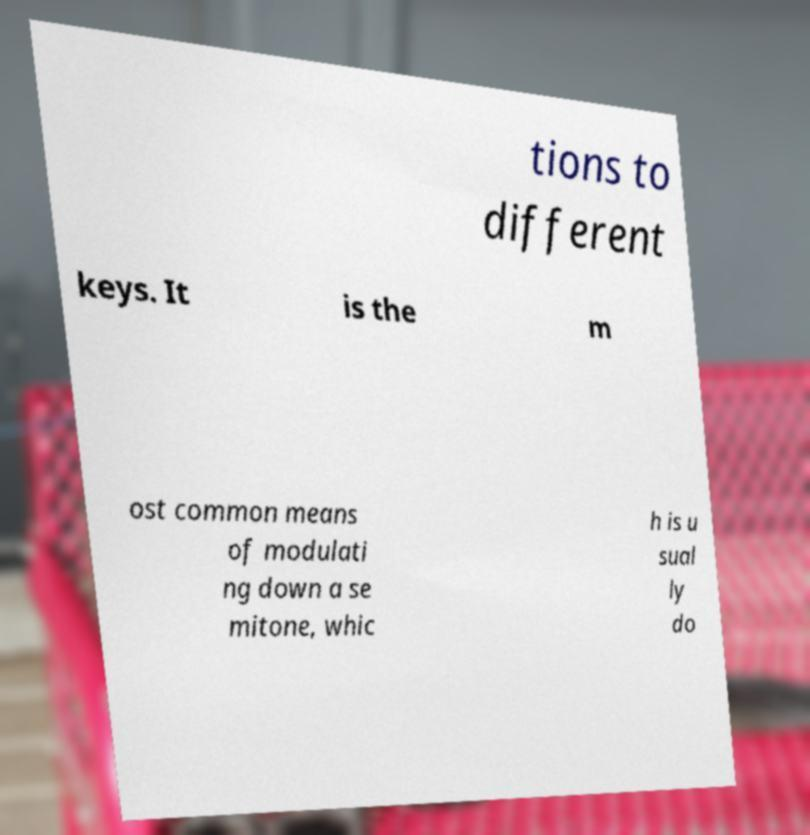What messages or text are displayed in this image? I need them in a readable, typed format. tions to different keys. It is the m ost common means of modulati ng down a se mitone, whic h is u sual ly do 